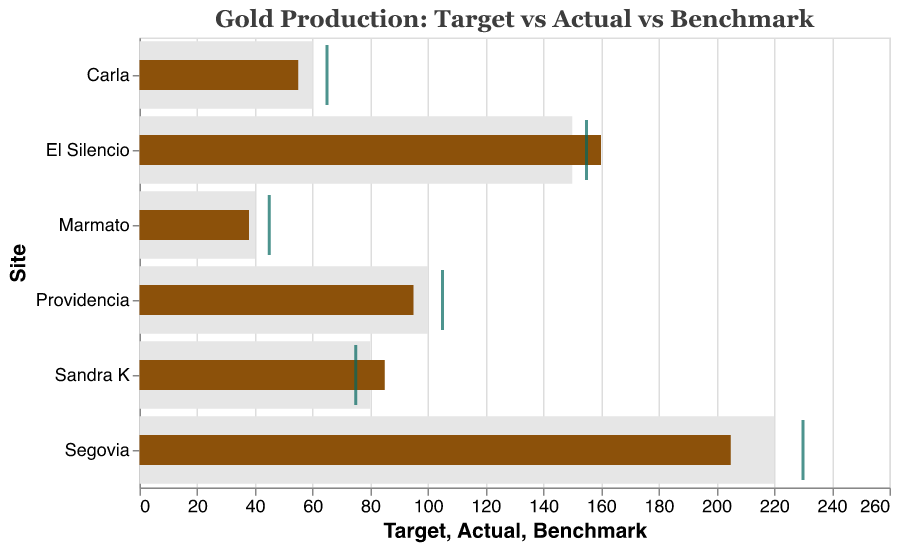what is the target gold production for El Silencio? The bar labeled 'Target' for El Silencio shows a value of 150.
Answer: 150 Which site achieved the highest actual gold production? The bars labeled 'Actual' show that El Silencio has the highest value at 160.
Answer: El Silencio What is the benchmark value for Marmato? The tick mark for Marmato shows a value of 45.
Answer: 45 By how much does Carla's actual production fall short of its target? Carla's target is 60 and actual is 55, so the shortfall is 60 - 55 = 5.
Answer: 5 Which site exceeded its target by the largest margin? Sandra K's target is 80 and actual is 85, hence exceeding by 5.
Answer: Sandra K Is the actual production for Providencia above or below its benchmark? Providencia's actual is 95 and benchmark is 105, so it is below.
Answer: Below What is the average target gold production across all sites? Sum the targets: 220 + 150 + 100 + 80 + 60 + 40 = 650. The average is 650 / 6 ≈ 108.33.
Answer: 108.33 Which site has the closest actual production to its benchmark? El Silencio's actual is 160 and its benchmark is 155, a difference of 5, the smallest difference among all sites.
Answer: El Silencio For which site is the target production lower than its benchmark but the actual production higher than its target? Sandra K has a target of 80, a benchmark of 75, and an actual of 85.
Answer: Sandra K 